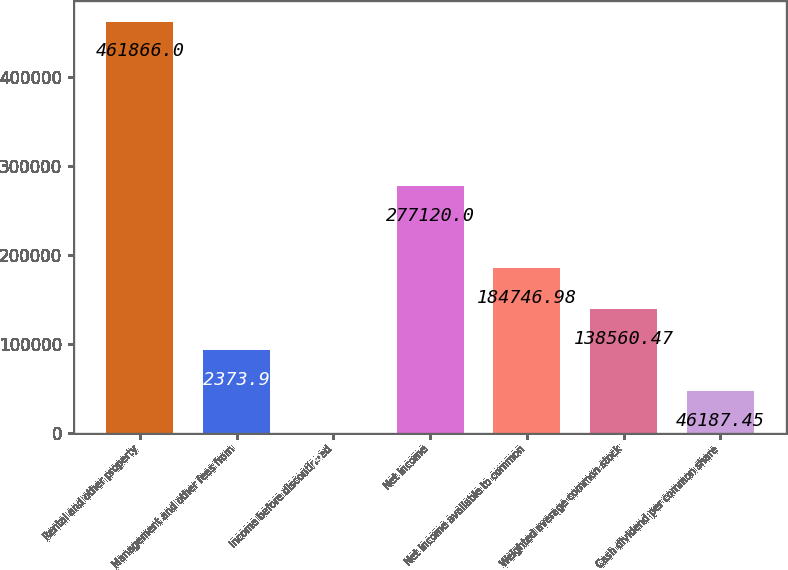Convert chart. <chart><loc_0><loc_0><loc_500><loc_500><bar_chart><fcel>Rental and other property<fcel>Management and other fees from<fcel>Income before discontinued<fcel>Net income<fcel>Net income available to common<fcel>Weighted average common stock<fcel>Cash dividend per common share<nl><fcel>461866<fcel>92374<fcel>0.94<fcel>277120<fcel>184747<fcel>138560<fcel>46187.4<nl></chart> 